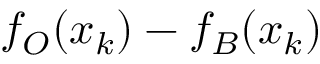Convert formula to latex. <formula><loc_0><loc_0><loc_500><loc_500>f _ { O } ( x _ { k } ) - f _ { B } ( x _ { k } )</formula> 